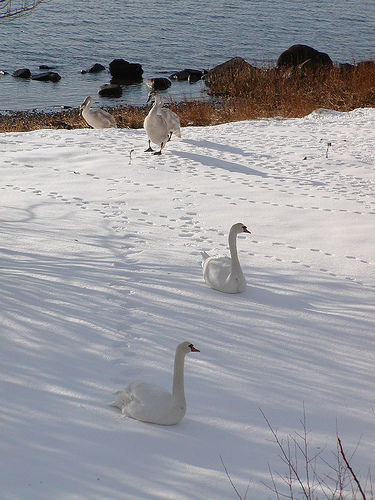<image>
Is there a bird under the lake? No. The bird is not positioned under the lake. The vertical relationship between these objects is different. 